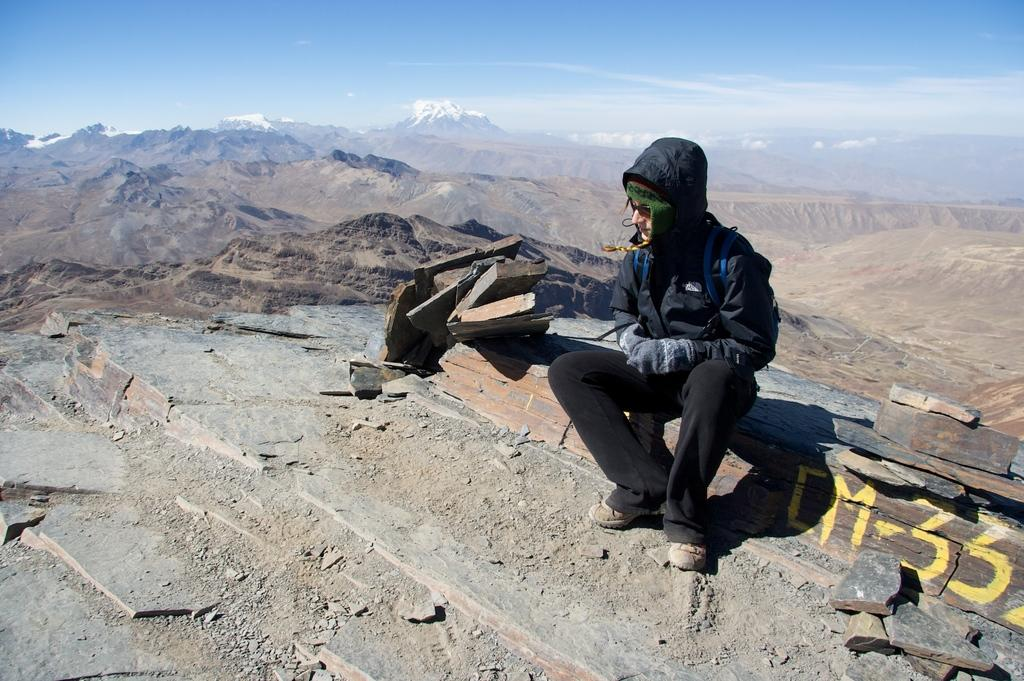What is the person in the image doing? The person is sitting on a rock in the image. What is written or depicted on the rock? There is text on the rock. What type of landscape can be seen in the background? There are mountains visible behind the person. What is visible at the top of the image? The sky is visible at the top of the image. What type of crime is being committed in the image? There is no crime being committed in the image; it shows a person sitting on a rock with mountains in the background. What unit of measurement is used to determine the height of the mountains in the image? The facts provided do not mention any specific unit of measurement for the mountains' height, so it cannot be determined from the image. 